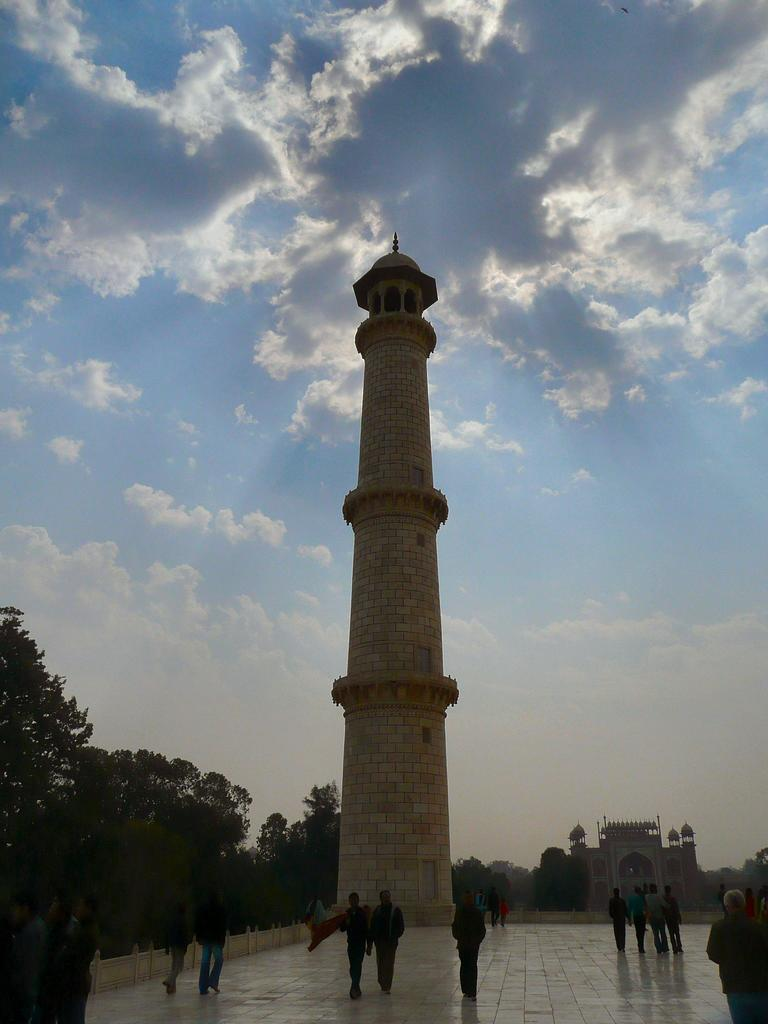What type of structure can be seen in the image? There is a fort in the image. What other architectural feature is present in the image? There is a tower in the image. What type of natural environment is visible in the image? There are trees in the image. What are the people in the image doing? There are people walking in the image. What colors are used to depict the sky in the image? The sky is in white and blue color. What type of achiever is being celebrated in the image? There is no indication of an achiever being celebrated in the image. How are the items in the image being sorted? There is no sorting activity depicted in the image. 